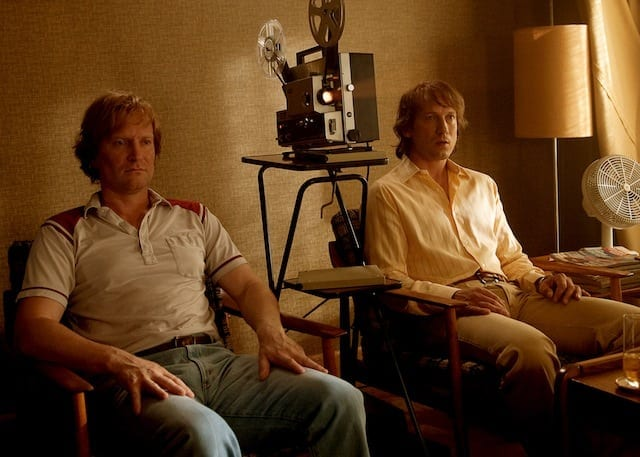Could you describe the mood of the room as depicted in this scene? The room portrays a subdued and contemplative mood. The dim lighting and warm color tones, along with the relaxed posture of the individuals, contribute to a calm and introspective atmosphere. The presence of a film projector and a fan also suggest a functional yet creative setting meant for filmic discussions or viewing. 